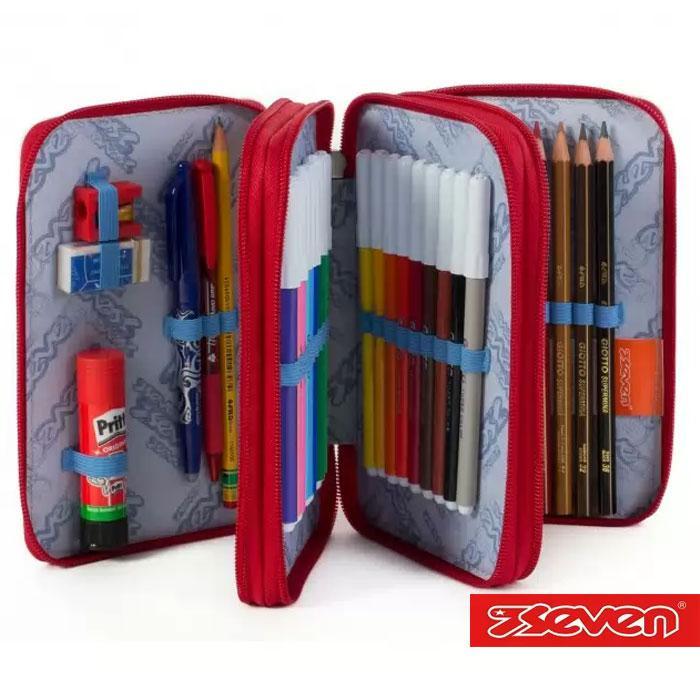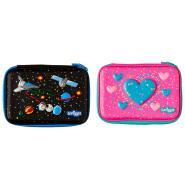The first image is the image on the left, the second image is the image on the right. For the images displayed, is the sentence "the left image shows two zippers on the pencil pouch top" factually correct? Answer yes or no. No. The first image is the image on the left, the second image is the image on the right. Assess this claim about the two images: "The brand logo is visible on the outside of both pouches.". Correct or not? Answer yes or no. No. 